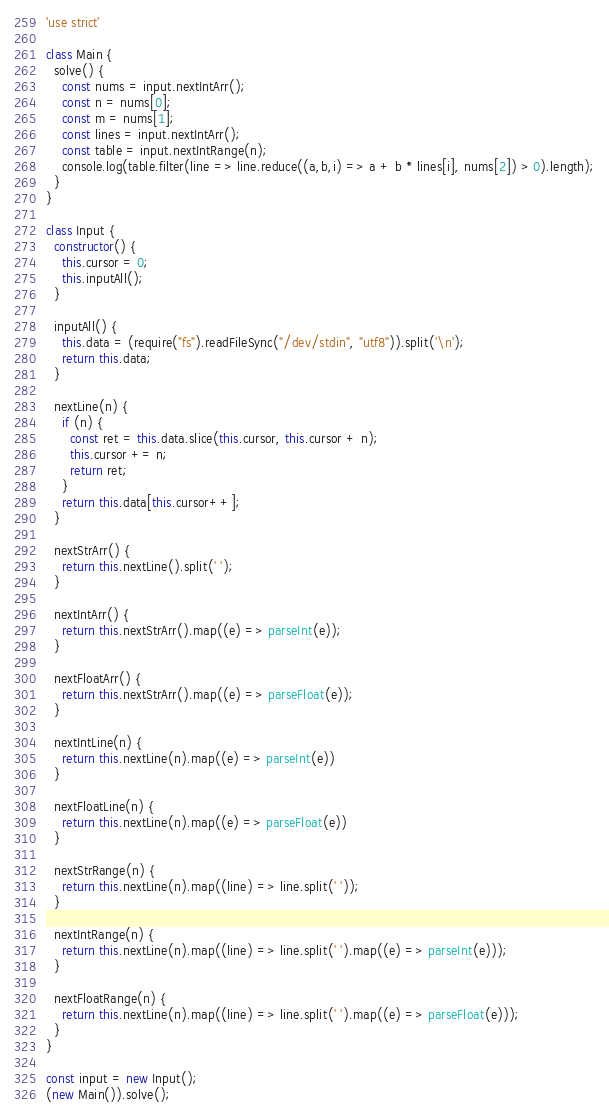Convert code to text. <code><loc_0><loc_0><loc_500><loc_500><_JavaScript_>'use strict'

class Main {
  solve() {
    const nums = input.nextIntArr();
    const n = nums[0];
    const m = nums[1];
    const lines = input.nextIntArr();
    const table = input.nextIntRange(n);
    console.log(table.filter(line => line.reduce((a,b,i) => a + b * lines[i], nums[2]) > 0).length);
  }
}

class Input {
  constructor() {
	this.cursor = 0;
	this.inputAll();
  }

  inputAll() {
	this.data = (require("fs").readFileSync("/dev/stdin", "utf8")).split('\n');
	return this.data;
  }

  nextLine(n) {
	if (n) {
	  const ret = this.data.slice(this.cursor, this.cursor + n);
	  this.cursor += n;
	  return ret;
	}
	return this.data[this.cursor++];
  }

  nextStrArr() {
	return this.nextLine().split(' ');
  }

  nextIntArr() {
	return this.nextStrArr().map((e) => parseInt(e));
  }

  nextFloatArr() {
	return this.nextStrArr().map((e) => parseFloat(e));
  }

  nextIntLine(n) {
	return this.nextLine(n).map((e) => parseInt(e))
  }

  nextFloatLine(n) {
	return this.nextLine(n).map((e) => parseFloat(e))
  }

  nextStrRange(n) {
	return this.nextLine(n).map((line) => line.split(' '));
  }

  nextIntRange(n) {
	return this.nextLine(n).map((line) => line.split(' ').map((e) => parseInt(e)));
  }

  nextFloatRange(n) {
	return this.nextLine(n).map((line) => line.split(' ').map((e) => parseFloat(e)));
  }
}

const input = new Input();
(new Main()).solve();
</code> 